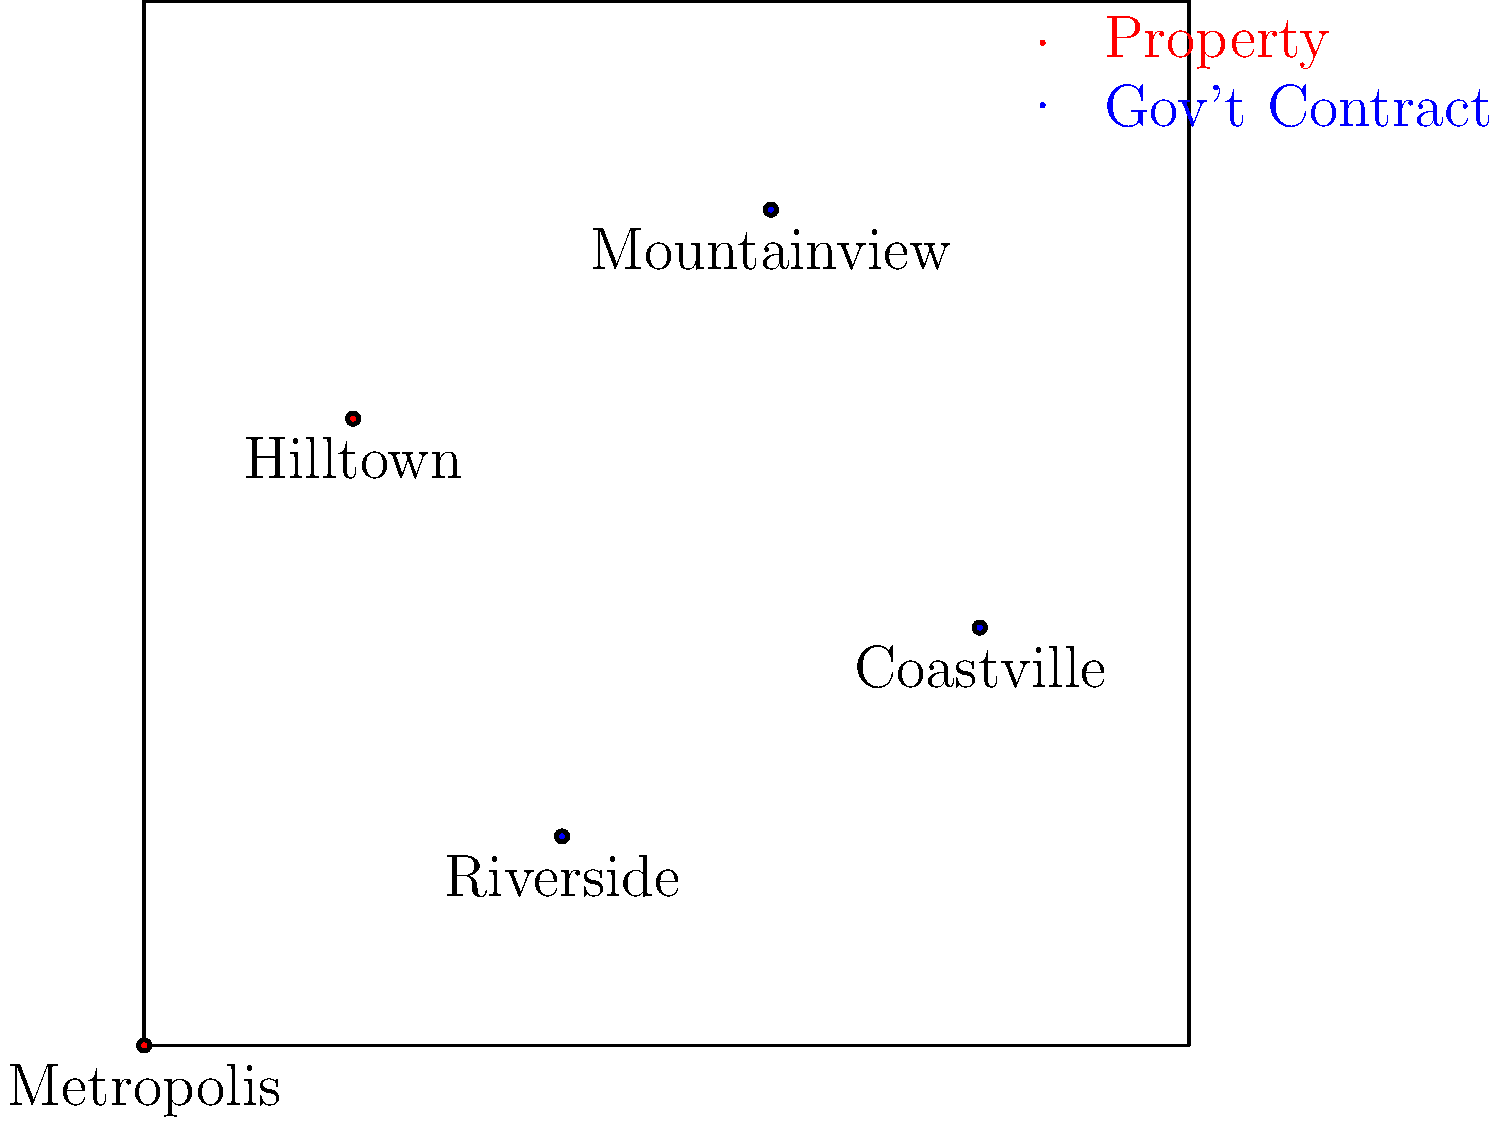Based on the map showing the real estate mogul's properties and government contracts in different cities, which city appears to have both a property owned by the mogul and a government contract, potentially indicating a direct conflict of interest? To identify a potential direct conflict of interest, we need to find a city where the mogul owns a property (marked in red) and has a government contract (marked in blue). Let's examine each city:

1. Metropolis: Has a property (red marker) but no government contract.
2. Riverside: Has a government contract (blue marker) but no property.
3. Hilltown: Has a property (red marker) but no government contract.
4. Coastville: Has a government contract (blue marker) but no property.
5. Mountainview: Has both a property (red marker) and a government contract (blue marker).

Mountainview is the only city that shows both a property owned by the mogul and a government contract, indicating a potential direct conflict of interest.
Answer: Mountainview 